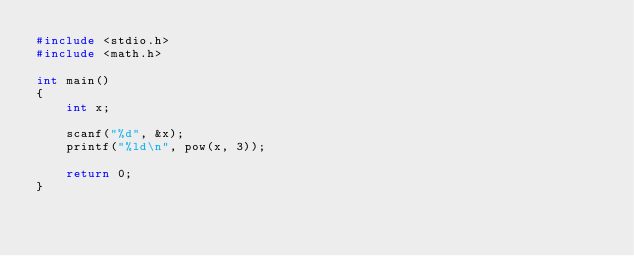Convert code to text. <code><loc_0><loc_0><loc_500><loc_500><_C_>#include <stdio.h>
#include <math.h>

int main()
{
    int x;

    scanf("%d", &x);
    printf("%ld\n", pow(x, 3));

    return 0;
}</code> 